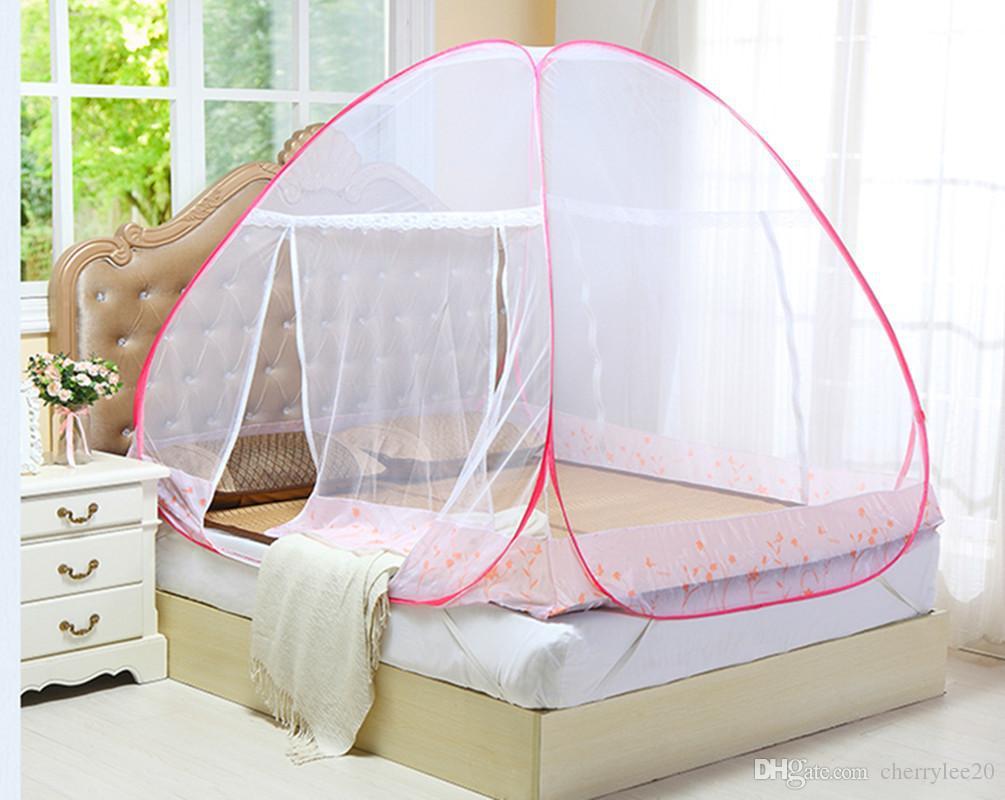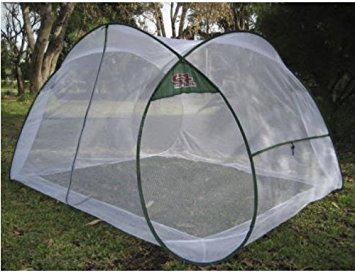The first image is the image on the left, the second image is the image on the right. Considering the images on both sides, is "A canopy screen is sitting on bare grass with nothing under it." valid? Answer yes or no. Yes. The first image is the image on the left, the second image is the image on the right. Considering the images on both sides, is "there are two white pillows in the image on the left" valid? Answer yes or no. No. 